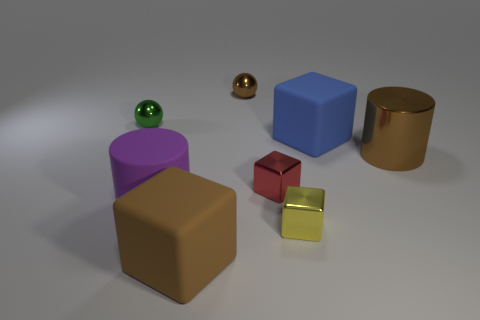The blue rubber thing that is the same size as the brown cube is what shape?
Your answer should be compact. Cube. What shape is the big matte thing that is the same color as the metal cylinder?
Make the answer very short. Cube. How many cyan metallic cylinders are there?
Your answer should be compact. 0. Is the material of the red object that is in front of the tiny green metallic thing the same as the brown object that is behind the green sphere?
Keep it short and to the point. Yes. There is a red cube that is made of the same material as the tiny yellow block; what size is it?
Your answer should be compact. Small. There is a brown thing that is behind the brown metallic cylinder; what shape is it?
Make the answer very short. Sphere. There is a small metal sphere right of the purple object; is its color the same as the metal cylinder to the right of the green metallic sphere?
Your answer should be very brief. Yes. There is a rubber object that is the same color as the shiny cylinder; what is its size?
Keep it short and to the point. Large. Are there any brown metal cylinders?
Keep it short and to the point. Yes. What shape is the brown object that is in front of the big cylinder that is to the left of the brown metal thing that is to the right of the large blue cube?
Your response must be concise. Cube. 